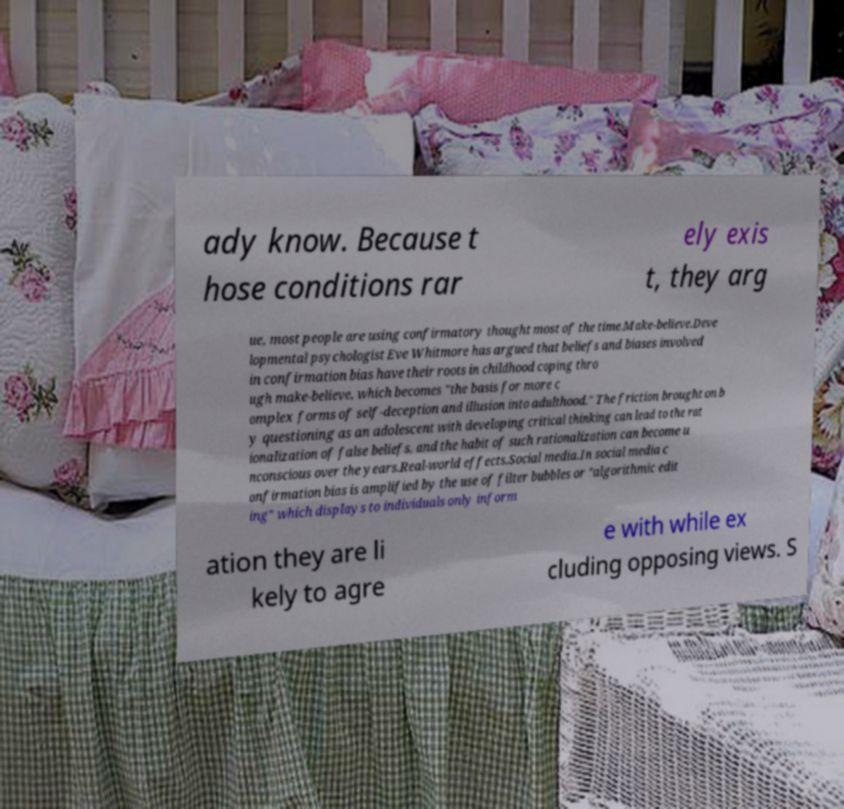Could you assist in decoding the text presented in this image and type it out clearly? ady know. Because t hose conditions rar ely exis t, they arg ue, most people are using confirmatory thought most of the time.Make-believe.Deve lopmental psychologist Eve Whitmore has argued that beliefs and biases involved in confirmation bias have their roots in childhood coping thro ugh make-believe, which becomes "the basis for more c omplex forms of self-deception and illusion into adulthood." The friction brought on b y questioning as an adolescent with developing critical thinking can lead to the rat ionalization of false beliefs, and the habit of such rationalization can become u nconscious over the years.Real-world effects.Social media.In social media c onfirmation bias is amplified by the use of filter bubbles or "algorithmic edit ing" which displays to individuals only inform ation they are li kely to agre e with while ex cluding opposing views. S 